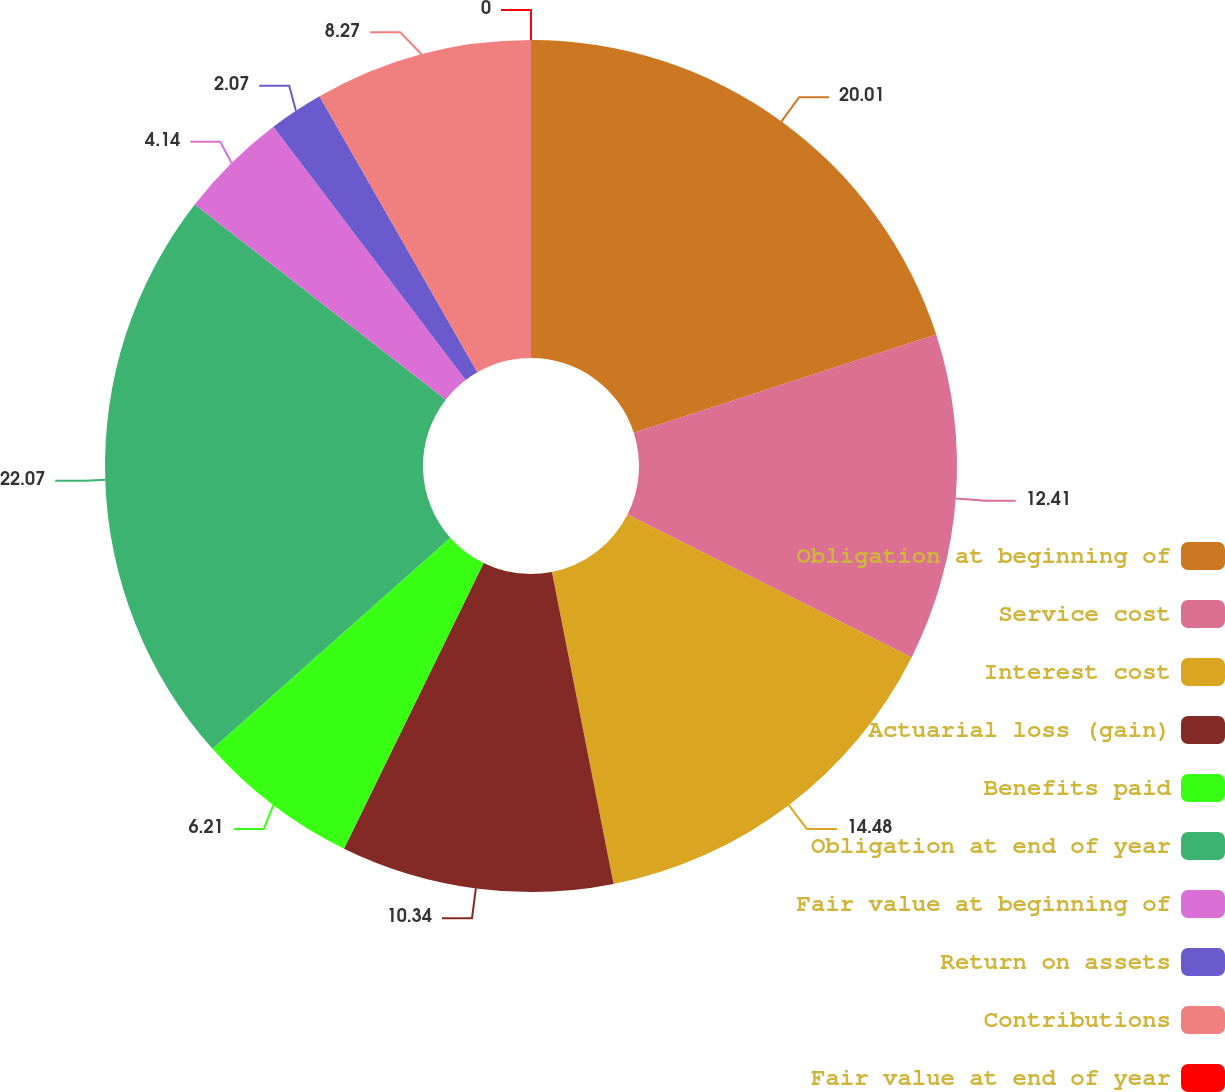Convert chart to OTSL. <chart><loc_0><loc_0><loc_500><loc_500><pie_chart><fcel>Obligation at beginning of<fcel>Service cost<fcel>Interest cost<fcel>Actuarial loss (gain)<fcel>Benefits paid<fcel>Obligation at end of year<fcel>Fair value at beginning of<fcel>Return on assets<fcel>Contributions<fcel>Fair value at end of year<nl><fcel>20.01%<fcel>12.41%<fcel>14.48%<fcel>10.34%<fcel>6.21%<fcel>22.08%<fcel>4.14%<fcel>2.07%<fcel>8.27%<fcel>0.0%<nl></chart> 